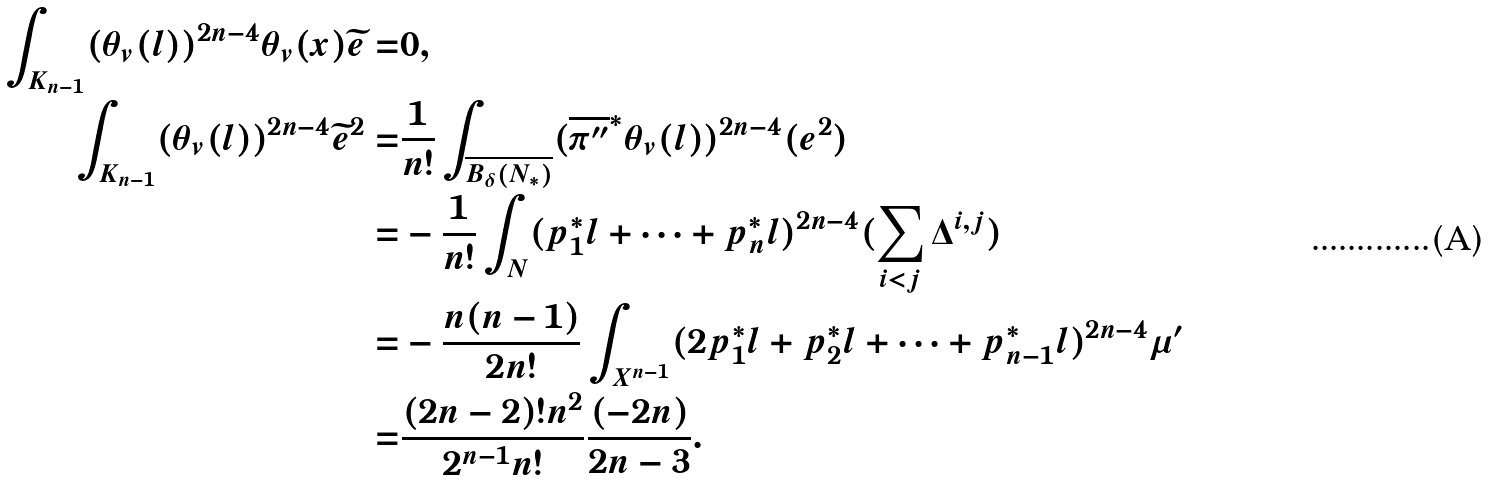Convert formula to latex. <formula><loc_0><loc_0><loc_500><loc_500>\int _ { K _ { n - 1 } } ( \theta _ { v } ( l ) ) ^ { 2 n - 4 } \theta _ { v } ( x ) \widetilde { e } = & 0 , \\ \int _ { K _ { n - 1 } } ( \theta _ { v } ( l ) ) ^ { 2 n - 4 } \widetilde { e } ^ { 2 } = & \frac { 1 } { n ! } \int _ { \overline { B _ { \delta } ( N _ { * } ) } } ( \overline { \pi ^ { \prime \prime } } ^ { * } \theta _ { v } ( l ) ) ^ { 2 n - 4 } ( e ^ { 2 } ) \\ = & - \frac { 1 } { n ! } \int _ { N } ( p _ { 1 } ^ { * } l + \dots + p _ { n } ^ { * } l ) ^ { 2 n - 4 } ( \sum _ { i < j } \Delta ^ { i , j } ) \\ = & - \frac { n ( n - 1 ) } { 2 n ! } \int _ { X ^ { n - 1 } } ( 2 p _ { 1 } ^ { * } l + p _ { 2 } ^ { * } l + \dots + p _ { n - 1 } ^ { * } l ) ^ { 2 n - 4 } \mu ^ { \prime } \\ = & \frac { ( 2 n - 2 ) ! n ^ { 2 } } { 2 ^ { n - 1 } n ! } \frac { ( - 2 n ) } { 2 n - 3 } .</formula> 